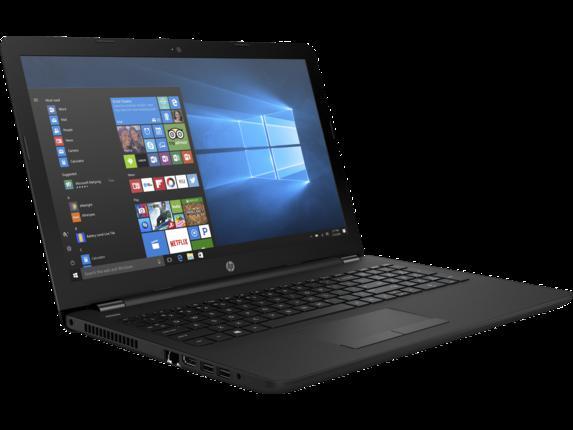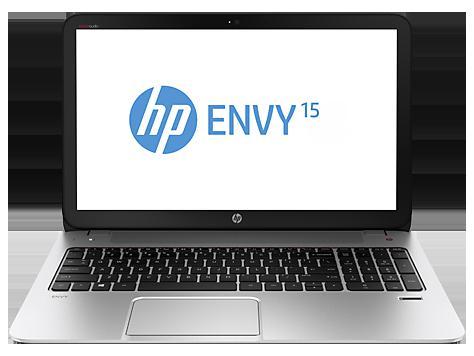The first image is the image on the left, the second image is the image on the right. For the images displayed, is the sentence "The image on the left shows a laptop with the keyboard not visible so it can be used as a tablet." factually correct? Answer yes or no. No. The first image is the image on the left, the second image is the image on the right. Given the left and right images, does the statement "One of the laptops is standing tent-like, with an image displaying outward on the inverted screen." hold true? Answer yes or no. No. 